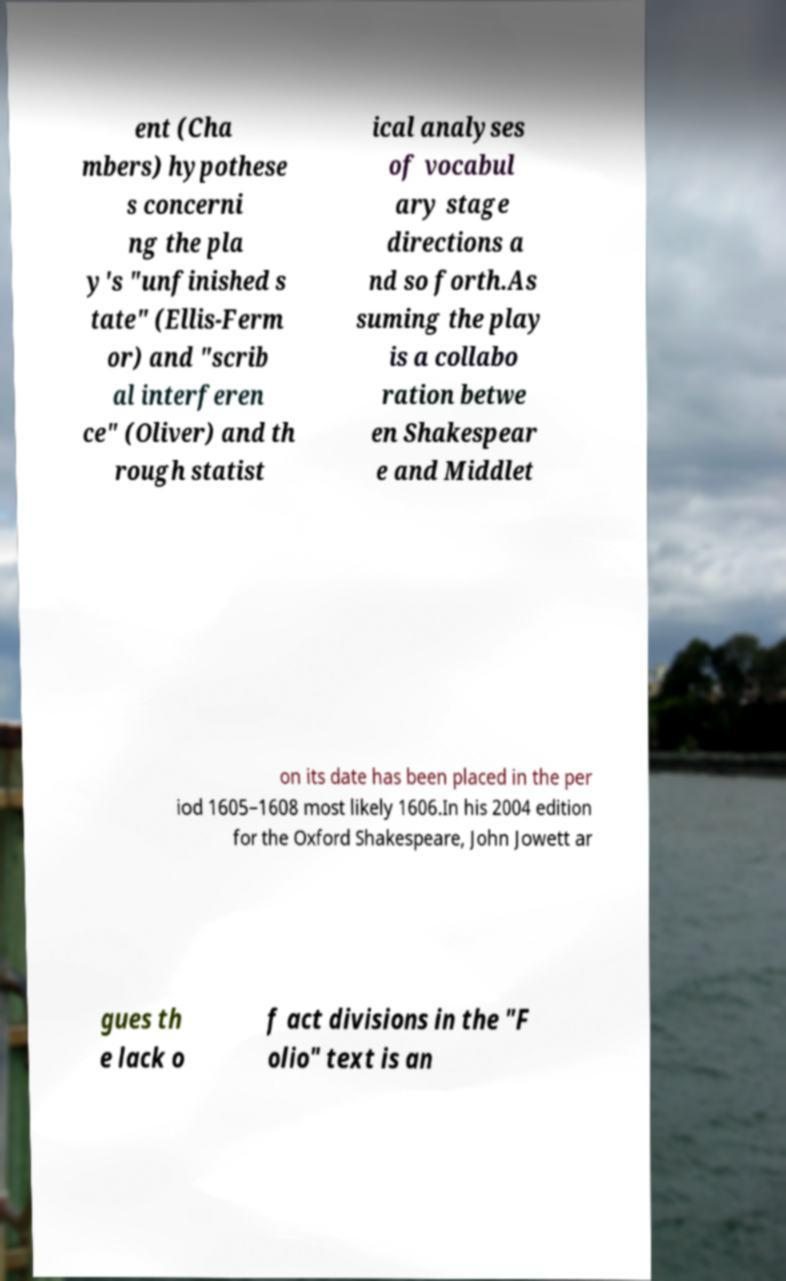Could you extract and type out the text from this image? ent (Cha mbers) hypothese s concerni ng the pla y's "unfinished s tate" (Ellis-Ferm or) and "scrib al interferen ce" (Oliver) and th rough statist ical analyses of vocabul ary stage directions a nd so forth.As suming the play is a collabo ration betwe en Shakespear e and Middlet on its date has been placed in the per iod 1605–1608 most likely 1606.In his 2004 edition for the Oxford Shakespeare, John Jowett ar gues th e lack o f act divisions in the "F olio" text is an 